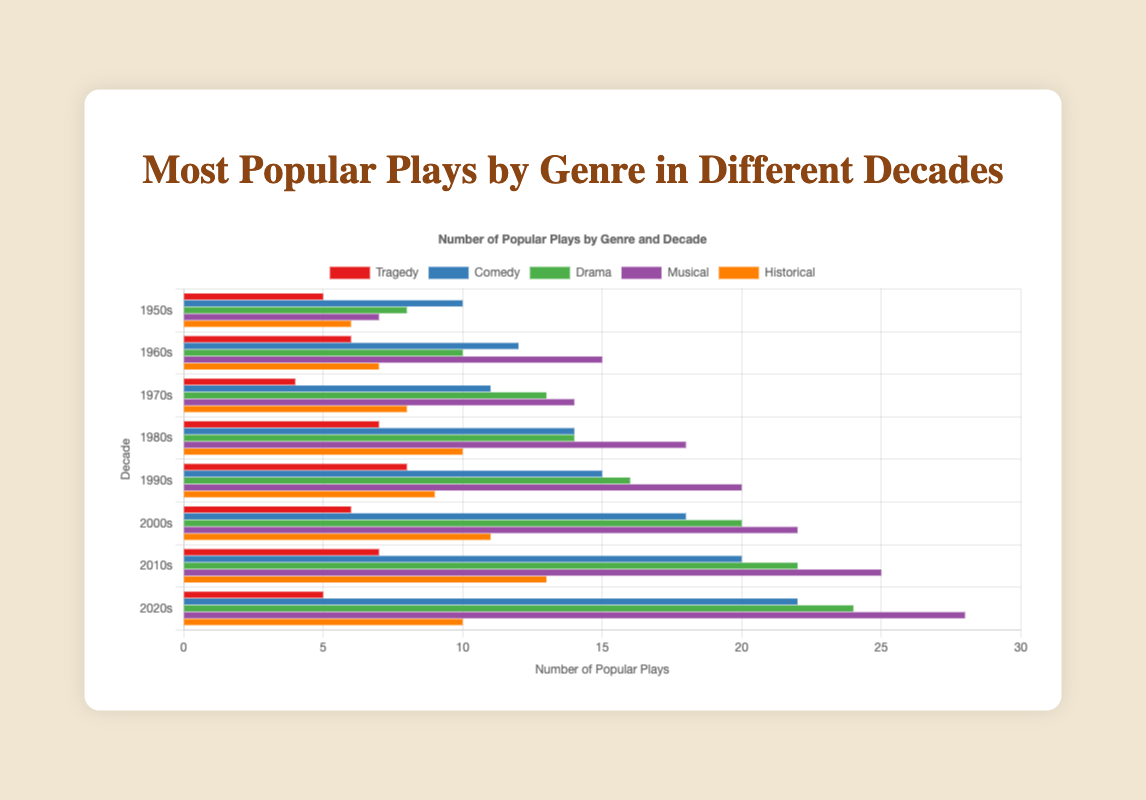Which genre was the most popular in the 2020s? By referring to the chart, the longest bar in the 2020s represents the most popular genre. The chart shows the longest bar for the 2020s is Musical, with 28 plays.
Answer: Musical How many more popular Musicals were there in the 1990s compared to the 1950s? According to the chart, the number of popular Musicals in the 1990s was 20, and in the 1950s, it was 7. The difference is 20 - 7.
Answer: 13 Which genre had the least variation in popularity from the 1950s to the 2020s? To determine the least variation, check the range (difference between the highest and lowest values) for each genre across the decades. Historical plays ranged from 6 to 13, giving a range of 7, indeed the smallest variation.
Answer: Historical How many total popular Comedies were there in the 1960s, 1970s, and 1980s combined? Sum the number of popular Comedies in the 1960s (12), 1970s (11), and 1980s (14). The total is 12 + 11 + 14.
Answer: 37 Which decade had the highest number of popular Tragedies? Compare the height of the Tragedy bars across all decades. The highest bar is 8 in the 1990s.
Answer: 1990s How did the popularity of Dramas change from the 1980s to the 2020s? The number of popular Dramas in the 1980s was 14 and increased to 24 in the 2020s. The change is 24 - 14, showing an increase.
Answer: Increased by 10 Which genre had the highest increase in the number of popular plays from the 1960s to the 2020s? Comparing each genre's values from 1960s to 2020s, Musical increased from 15 to 28. The increase is the highest, 28 - 15 = 13.
Answer: Musical What is the total number of popular plays across all genres in the 2000s? Sum the values for all genres in the 2000s: 6 (Tragedy) + 18 (Comedy) + 20 (Drama) + 22 (Musical) + 11 (Historical).
Answer: 77 Was the number of popular Comedies in the 2010s greater than the total number of Historical plays in the 2000s and 2010s combined? The number of popular Comedies in the 2010s is 20. The total number of Historical plays in the 2000s (11) and 2010s (13) combined is 24. 20 is less than 24.
Answer: No What genre is represented by the green bars? Identify the green-colored bars in the visualization, which correspond to the Drama genre as indicated in the legend.
Answer: Drama 